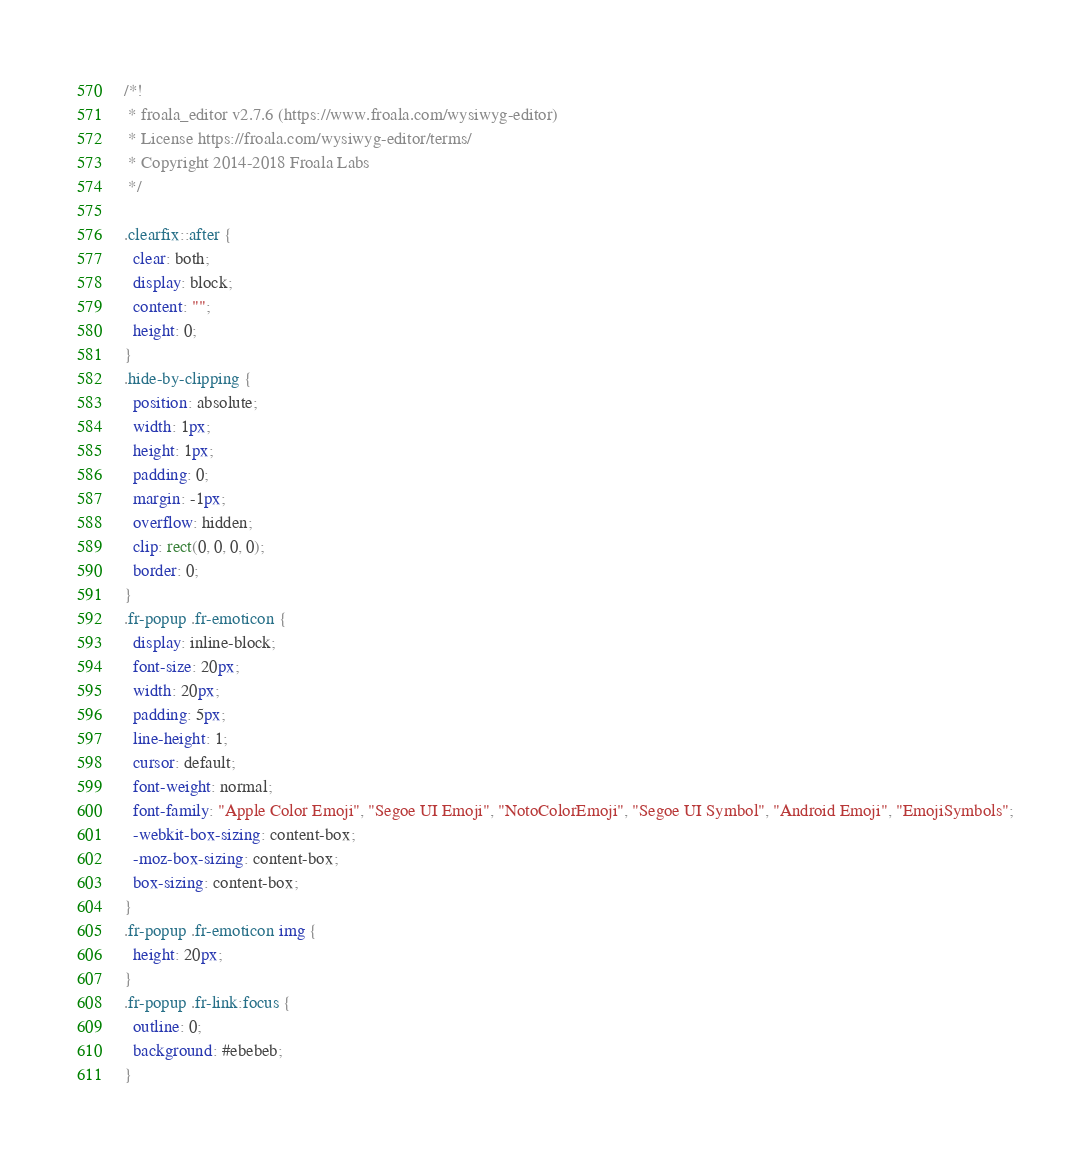<code> <loc_0><loc_0><loc_500><loc_500><_CSS_>/*!
 * froala_editor v2.7.6 (https://www.froala.com/wysiwyg-editor)
 * License https://froala.com/wysiwyg-editor/terms/
 * Copyright 2014-2018 Froala Labs
 */

.clearfix::after {
  clear: both;
  display: block;
  content: "";
  height: 0;
}
.hide-by-clipping {
  position: absolute;
  width: 1px;
  height: 1px;
  padding: 0;
  margin: -1px;
  overflow: hidden;
  clip: rect(0, 0, 0, 0);
  border: 0;
}
.fr-popup .fr-emoticon {
  display: inline-block;
  font-size: 20px;
  width: 20px;
  padding: 5px;
  line-height: 1;
  cursor: default;
  font-weight: normal;
  font-family: "Apple Color Emoji", "Segoe UI Emoji", "NotoColorEmoji", "Segoe UI Symbol", "Android Emoji", "EmojiSymbols";
  -webkit-box-sizing: content-box;
  -moz-box-sizing: content-box;
  box-sizing: content-box;
}
.fr-popup .fr-emoticon img {
  height: 20px;
}
.fr-popup .fr-link:focus {
  outline: 0;
  background: #ebebeb;
}
</code> 